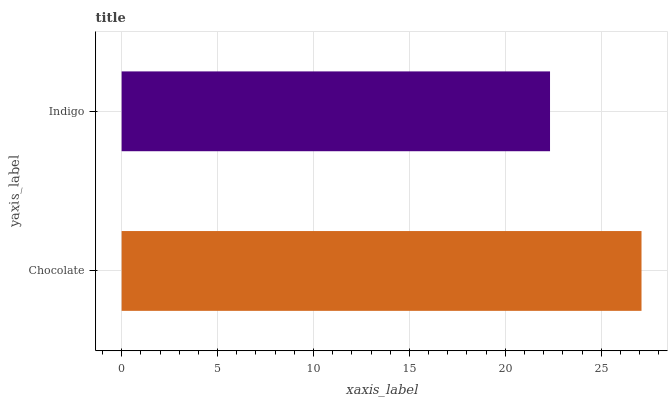Is Indigo the minimum?
Answer yes or no. Yes. Is Chocolate the maximum?
Answer yes or no. Yes. Is Indigo the maximum?
Answer yes or no. No. Is Chocolate greater than Indigo?
Answer yes or no. Yes. Is Indigo less than Chocolate?
Answer yes or no. Yes. Is Indigo greater than Chocolate?
Answer yes or no. No. Is Chocolate less than Indigo?
Answer yes or no. No. Is Chocolate the high median?
Answer yes or no. Yes. Is Indigo the low median?
Answer yes or no. Yes. Is Indigo the high median?
Answer yes or no. No. Is Chocolate the low median?
Answer yes or no. No. 